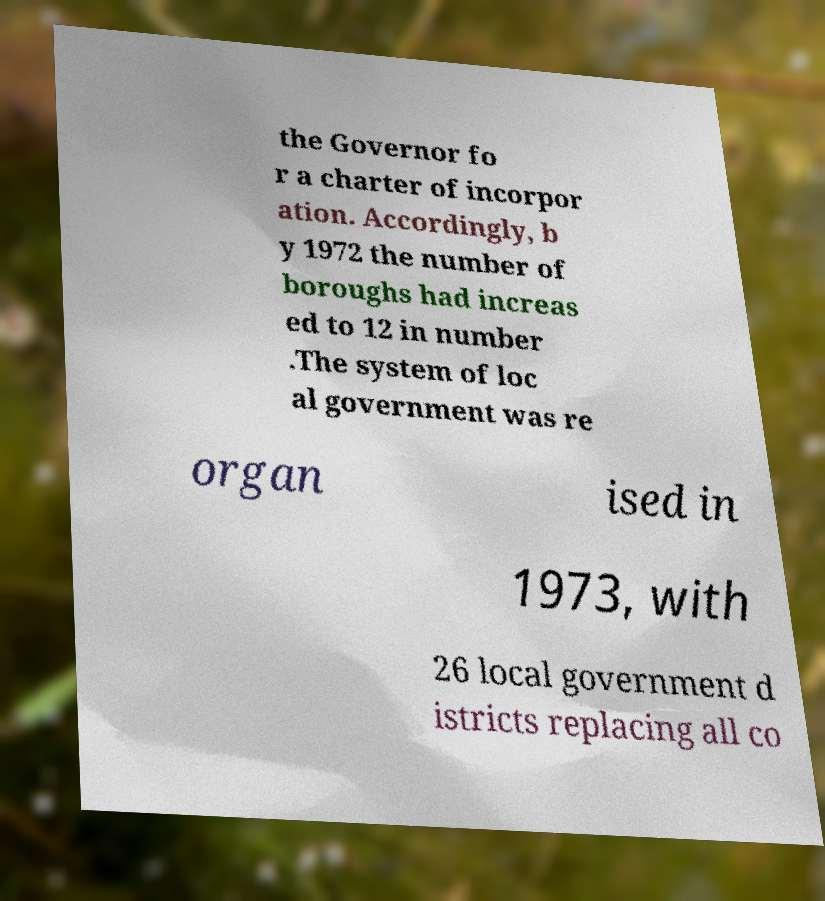Please read and relay the text visible in this image. What does it say? the Governor fo r a charter of incorpor ation. Accordingly, b y 1972 the number of boroughs had increas ed to 12 in number .The system of loc al government was re organ ised in 1973, with 26 local government d istricts replacing all co 